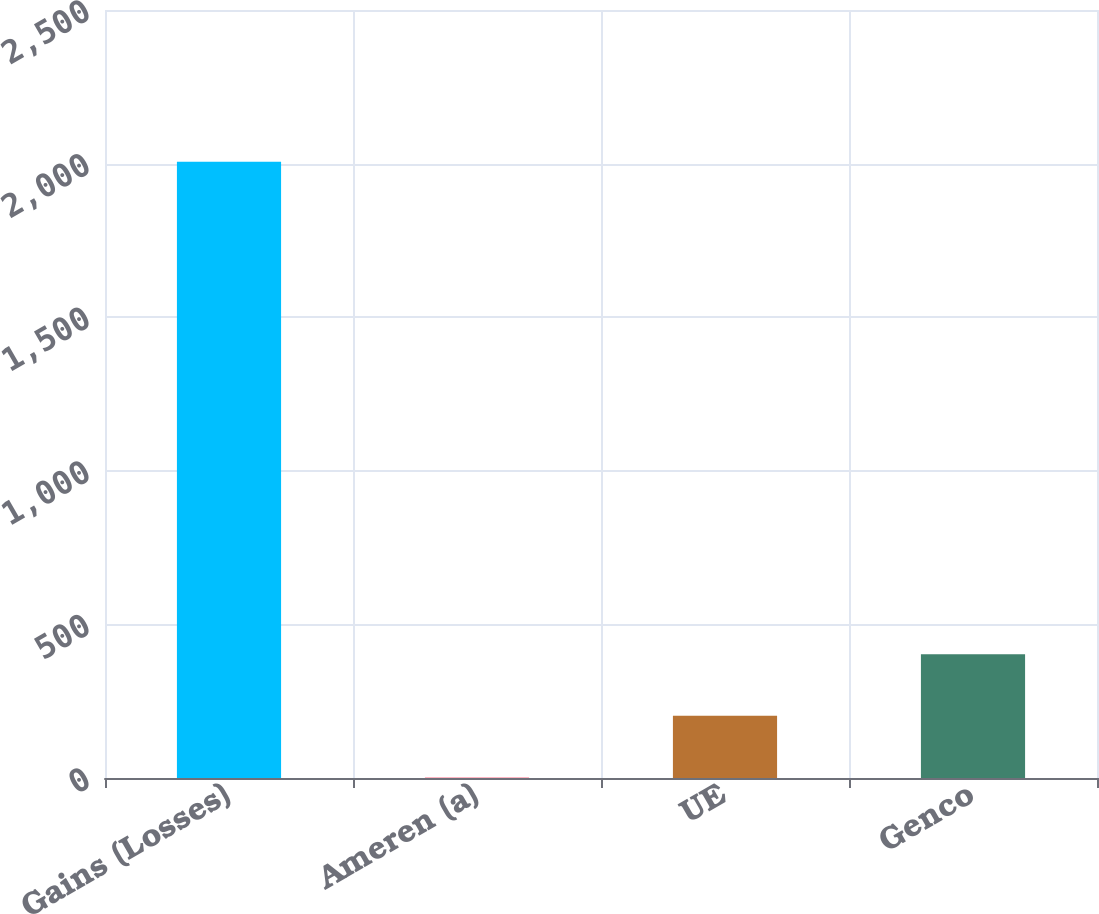<chart> <loc_0><loc_0><loc_500><loc_500><bar_chart><fcel>Gains (Losses)<fcel>Ameren (a)<fcel>UE<fcel>Genco<nl><fcel>2006<fcel>2<fcel>202.4<fcel>402.8<nl></chart> 